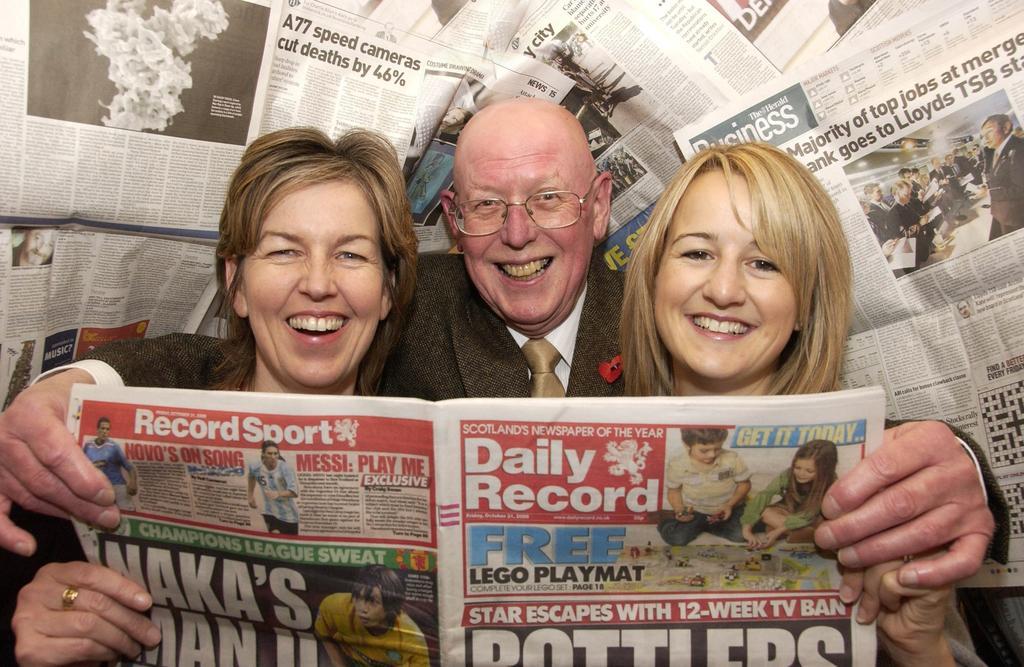In one or two sentences, can you explain what this image depicts? In this image we can see a man and two women holding the news paper in which we can see the pictures and some text on it. On the backside we can see some news papers. 